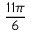<formula> <loc_0><loc_0><loc_500><loc_500>\frac { 1 1 \pi } { 6 }</formula> 